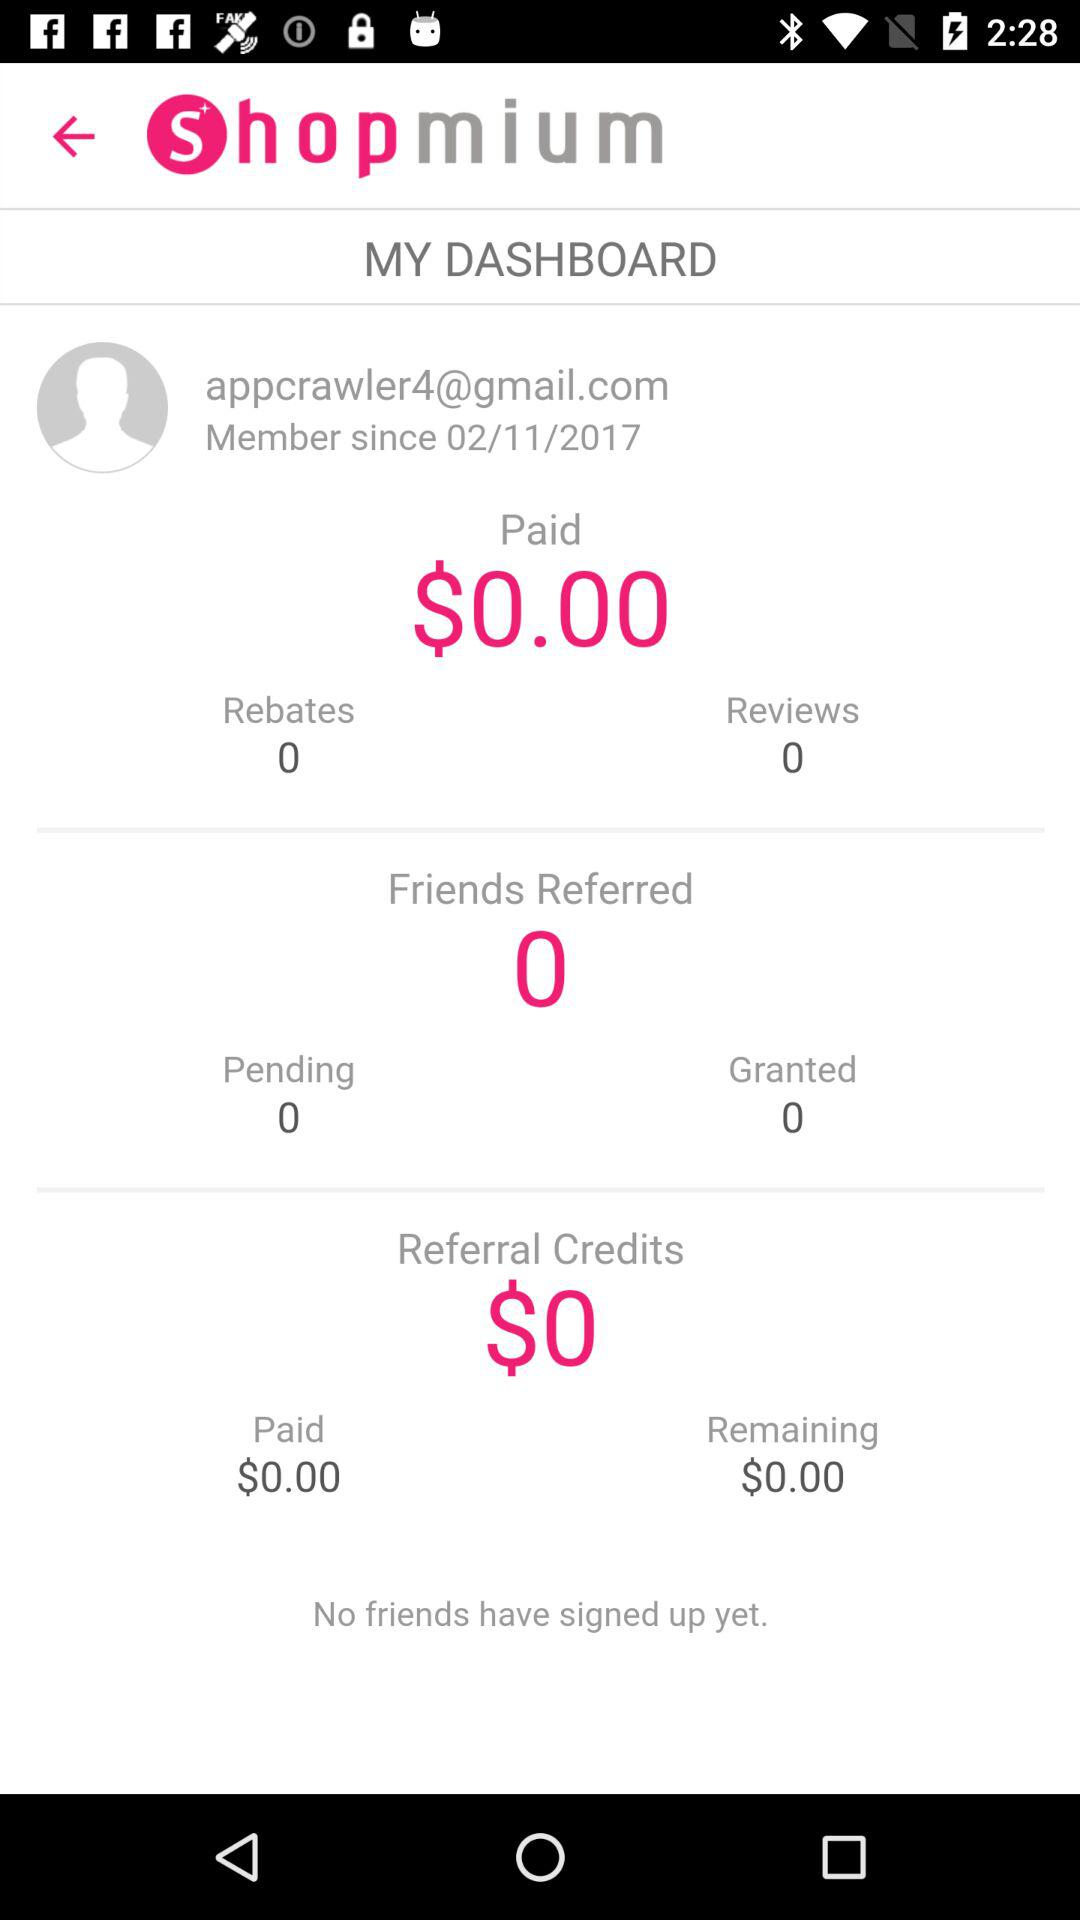Have any friends signed up? There is no friend who has signed up. 